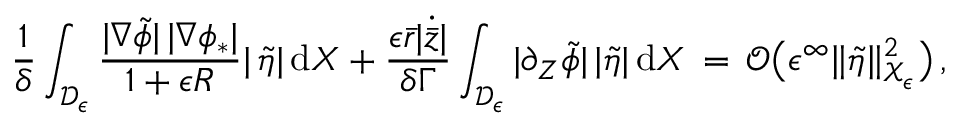Convert formula to latex. <formula><loc_0><loc_0><loc_500><loc_500>\frac { 1 } { \delta } \int _ { \mathcal { D } _ { \epsilon } } \frac { | \nabla \tilde { \phi } | \, | \nabla \phi _ { * } | } { 1 + \epsilon R } | \, \tilde { \eta } | \, d X + \frac { \epsilon \bar { r } | \dot { \bar { z } } | } { \delta \Gamma } \int _ { \mathcal { D } _ { \epsilon } } | \partial _ { Z } \tilde { \phi } | \, | \tilde { \eta } | \, d X \, = \, \mathcal { O } \left ( \epsilon ^ { \infty } \| \tilde { \eta } \| _ { \mathcal { X } _ { \epsilon } } ^ { 2 } \right ) \, ,</formula> 